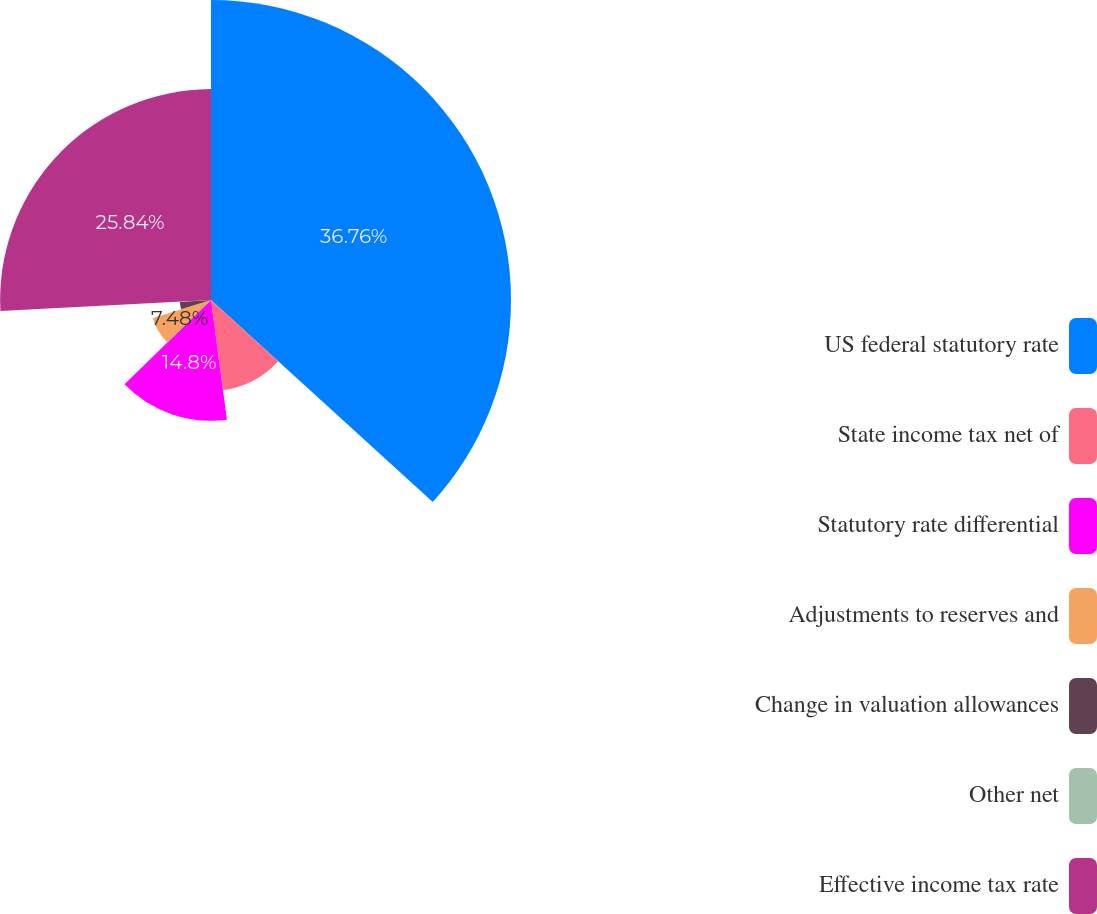<chart> <loc_0><loc_0><loc_500><loc_500><pie_chart><fcel>US federal statutory rate<fcel>State income tax net of<fcel>Statutory rate differential<fcel>Adjustments to reserves and<fcel>Change in valuation allowances<fcel>Other net<fcel>Effective income tax rate<nl><fcel>36.76%<fcel>11.14%<fcel>14.8%<fcel>7.48%<fcel>3.82%<fcel>0.16%<fcel>25.84%<nl></chart> 